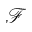<formula> <loc_0><loc_0><loc_500><loc_500>\mathcal { F }</formula> 